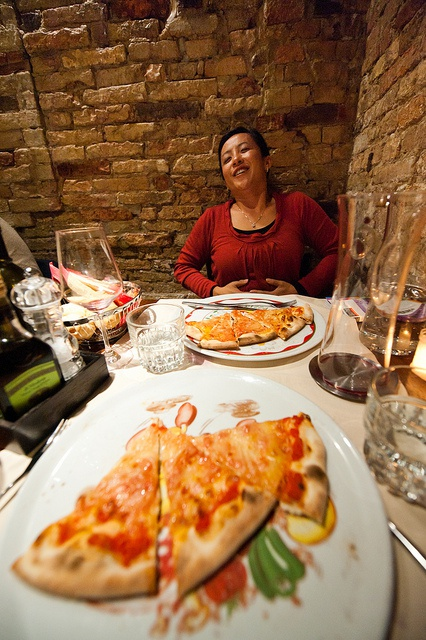Describe the objects in this image and their specific colors. I can see dining table in black, ivory, darkgray, orange, and tan tones, people in black, maroon, and brown tones, pizza in black, orange, and red tones, pizza in black, orange, and red tones, and pizza in black, orange, red, and brown tones in this image. 